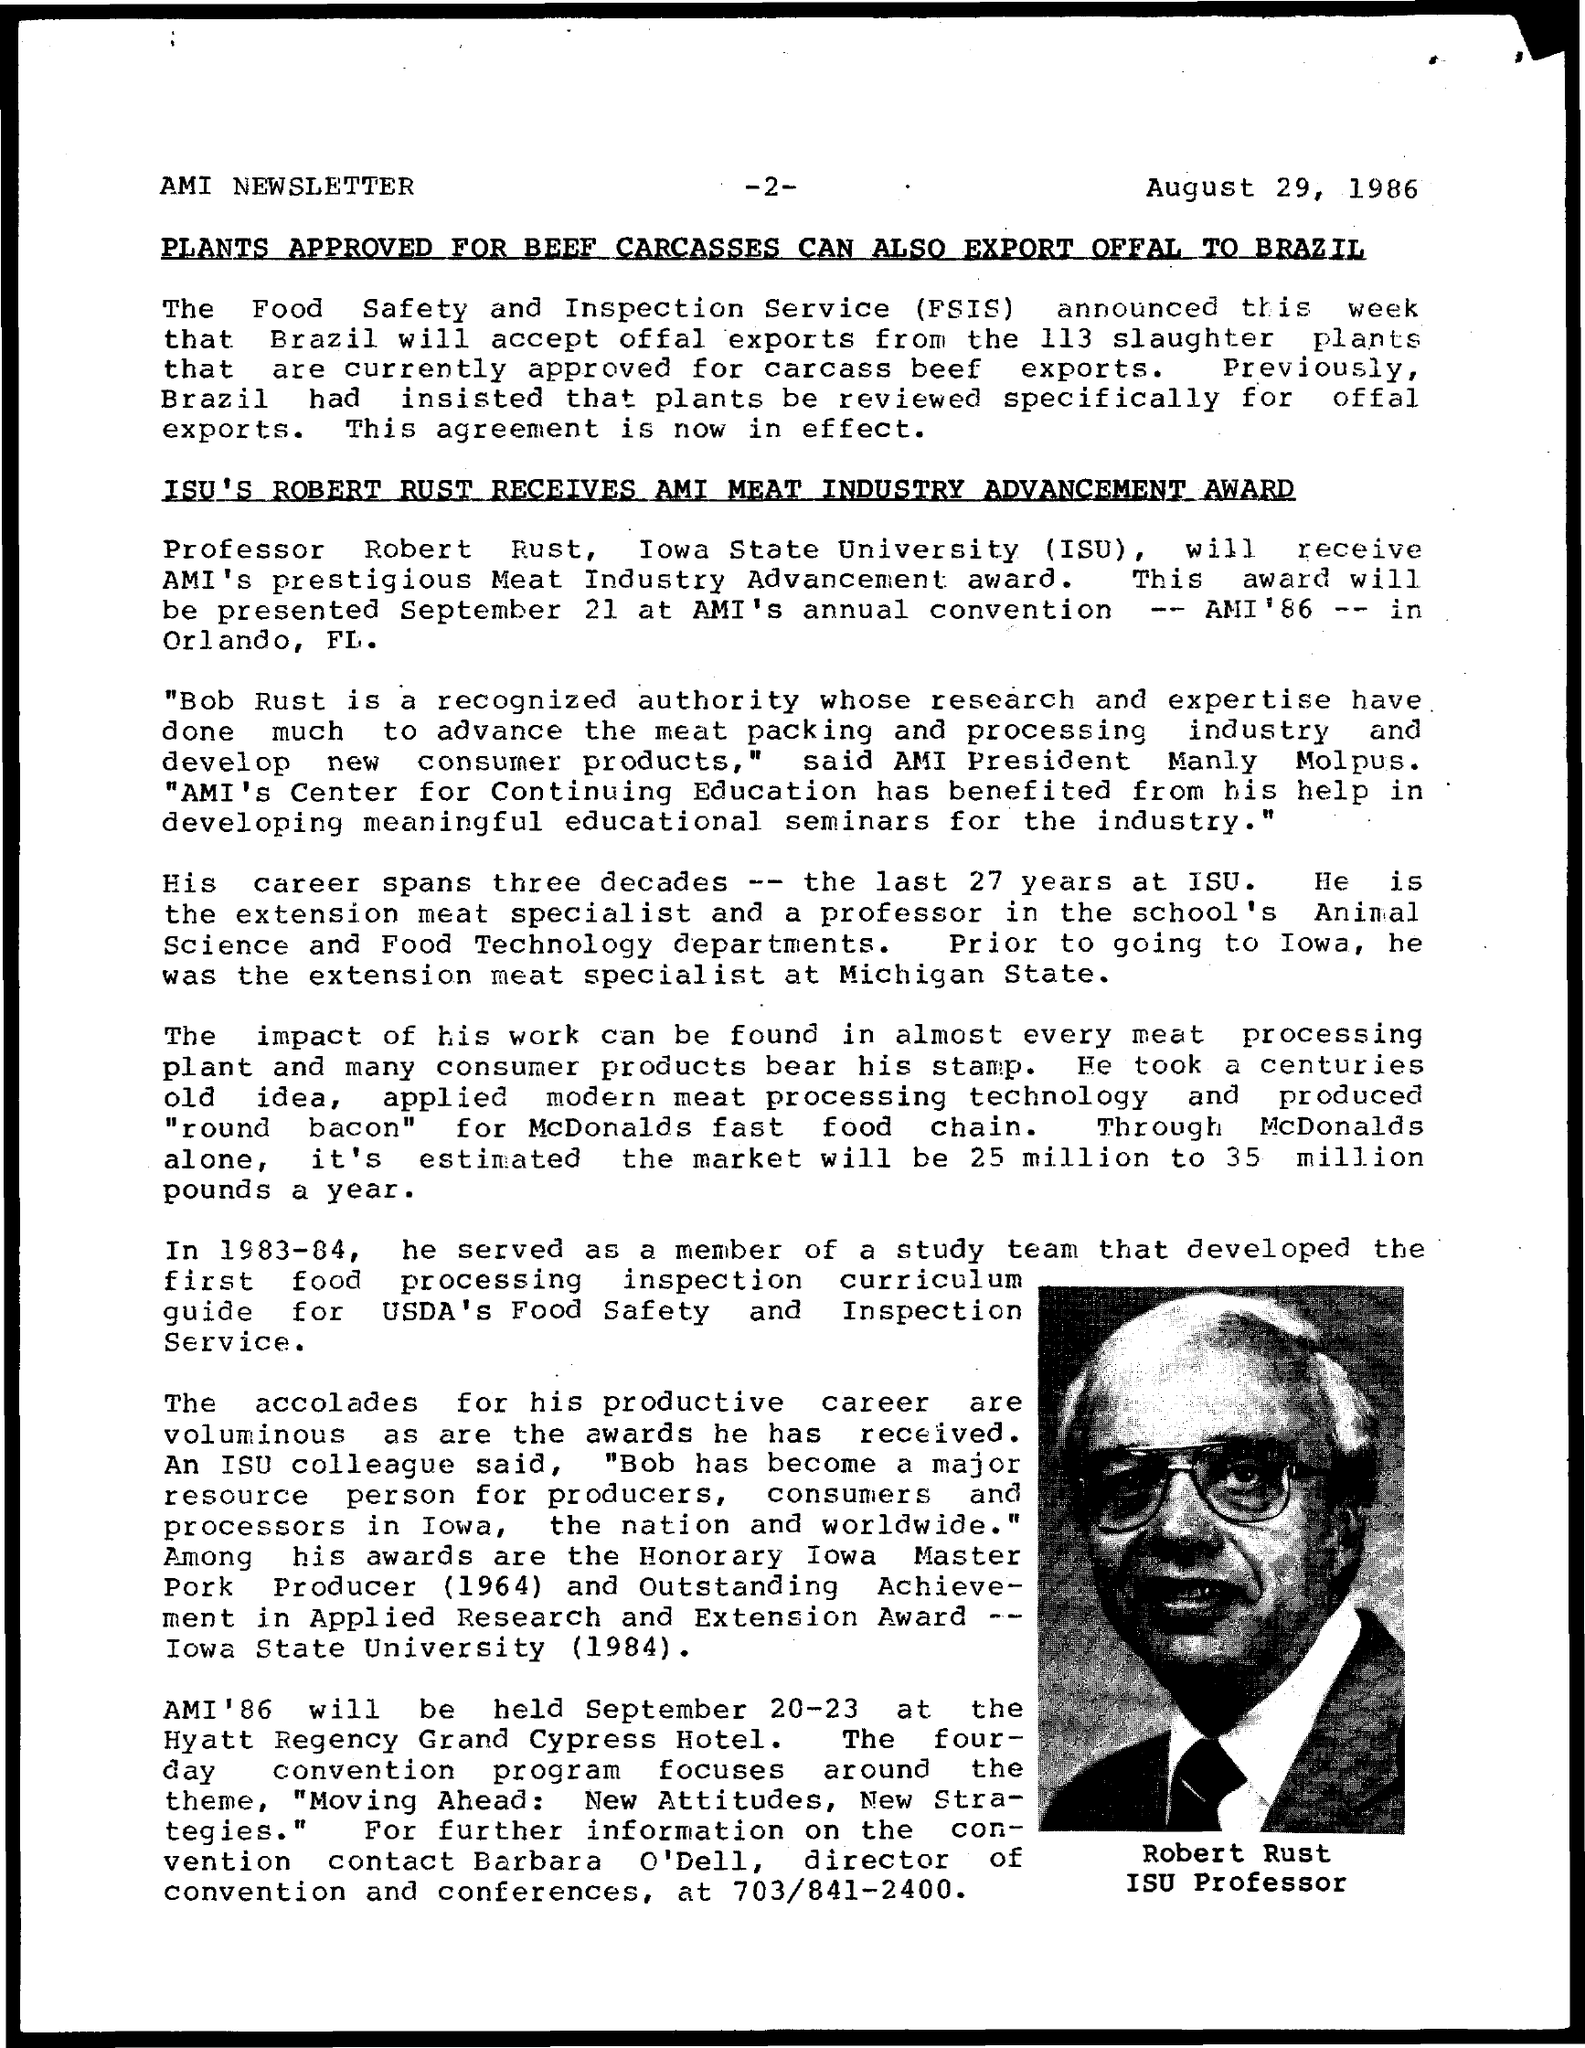What is the date mentioned in the given page ?
Provide a short and direct response. August 29, 1986. What is the full form of fsis ?
Provide a succinct answer. The Food Safety and Inspection Service. What is the full form of isu ?
Make the answer very short. Iowa State University. What is the name of the person which is shown in the page ?
Your answer should be compact. Robert Rust. 